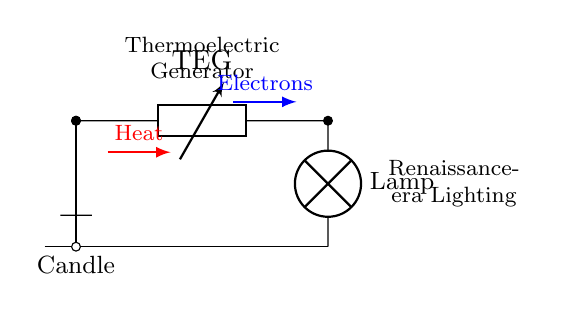What type of generator is used in this circuit? The circuit diagram identifies the generator as a thermoelectric generator (TEG) indicated by the label TEG. This is clearly shown between the two points connecting the heat source and the load.
Answer: thermoelectric generator What is the function of the candle in the circuit? The candle serves as a heat source, providing the necessary thermal energy to the thermoelectric generator to produce electrical energy. It is depicted at the beginning of the circuit and is key to the operation of the generator.
Answer: heat source What device is connected to the thermoelectric generator? The load connected to the thermoelectric generator is labeled as a 'Lamp,' indicating that the circuit is designed to power lighting, specifically a Renaissance-era lamp as noted in the diagram.
Answer: Lamp What direction do the electrons flow? The arrows indicating electron flow are labeled blue and point from the thermoelectric generator (TEG) toward the load (Lamp). This shows that the electrons move in a specific direction to power the lamp.
Answer: right How does heat contribute to the operation of the circuit? Heat from the candle is indicated by a red arrow pointing toward the thermoelectric generator, signifying that the thermal energy generated by the candle is essential for initiating the electrical generation process in the TEG.
Answer: initiates electrical generation How does the ground connect in this circuit? The ground connection is represented at the bottom of the circuit where the lamp is grounded back to the candle's connection point, ensuring that the circuit is complete and allowing current to flow throughout effectively.
Answer: ground connection What type of device is used for lighting in this circuit? The diagram explicitly identifies the lighting device as a 'Lamp,' indicating that the circuit is designed for illuminating purposes using a Renaissance-era lamp.
Answer: Lamp 